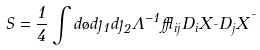Convert formula to latex. <formula><loc_0><loc_0><loc_500><loc_500>S = \frac { 1 } { 4 } \int d \tau d \eta _ { 1 } d \eta _ { 2 } \Lambda ^ { - 1 } \epsilon _ { i j } D _ { i } X _ { \mu } D _ { j } X ^ { \mu }</formula> 